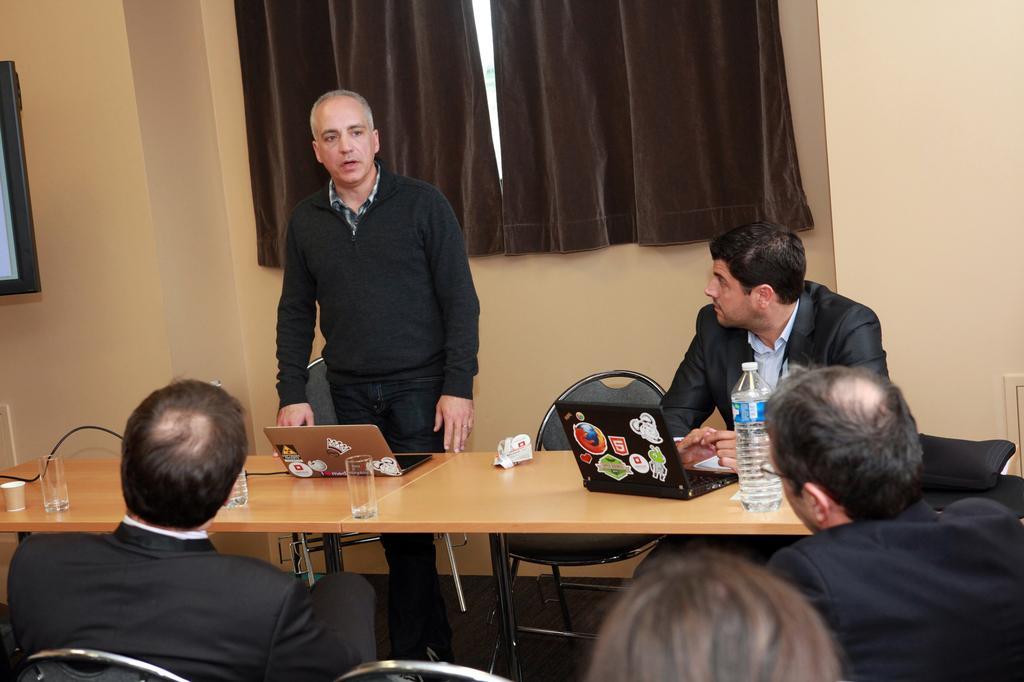Please provide a concise description of this image. In this image I can see the group of people sitting. Among them one person is standing. In front of them there is a laptop,bottle,glass on the table. At the back side there is a curtain and the frame attached to the wall. 